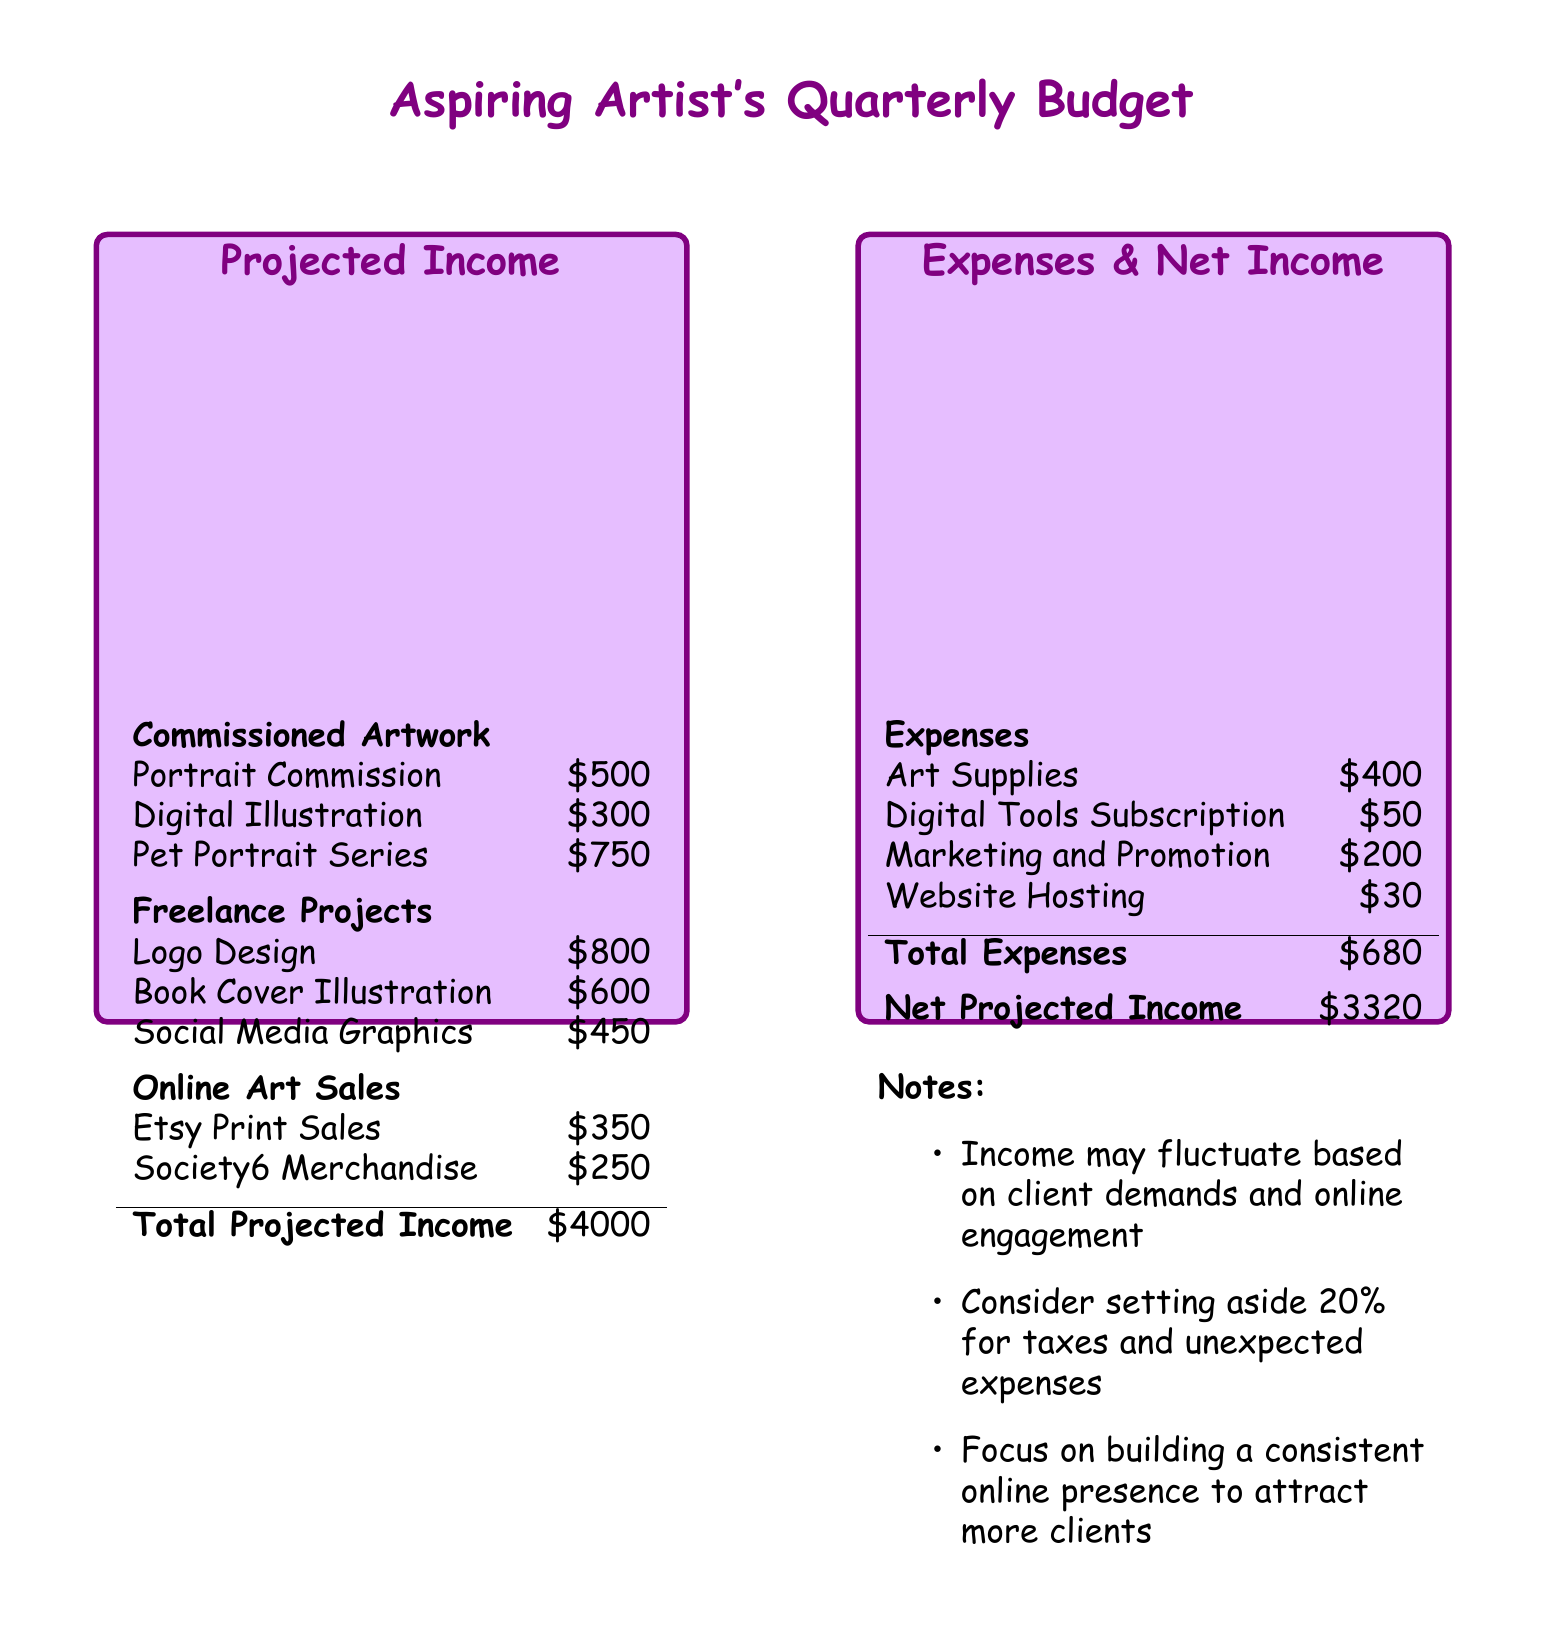what is the total projected income? The total projected income is the sum of all income sources listed in the document.
Answer: $4000 how much is the portrait commission? The portrait commission is one of the commissioned artworks listed in the income section.
Answer: $500 what is the total expenses amount? The total expenses is summarized in the expenses section of the document.
Answer: $680 what is the net projected income? The net projected income is calculated by subtracting total expenses from total projected income.
Answer: $3320 how much is allocated for art supplies? The document lists the art supplies as one of the expense items.
Answer: $400 which freelance project has the highest income? The freelance projects section lists various projects, and the one with the highest income is the logo design.
Answer: Logo Design what percentage should be set aside for taxes? Notes in the document recommend a percentage for taxes and unexpected expenses.
Answer: 20% how many different commissioned artworks are listed? The income section outlines the commissioned artworks in the budget.
Answer: 3 what is the total income from online art sales? The online art sales section summarizes income derived from these sales activities.
Answer: $600 